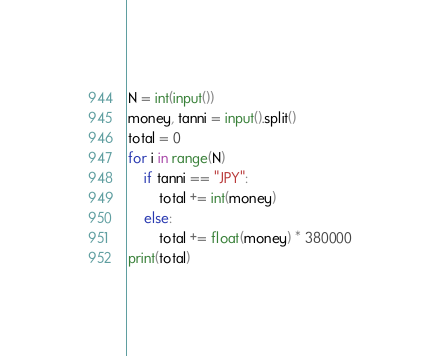<code> <loc_0><loc_0><loc_500><loc_500><_Python_>N = int(input())
money, tanni = input().split()
total = 0
for i in range(N)
    if tanni == "JPY":
        total += int(money)
    else:
        total += float(money) * 380000
print(total)</code> 